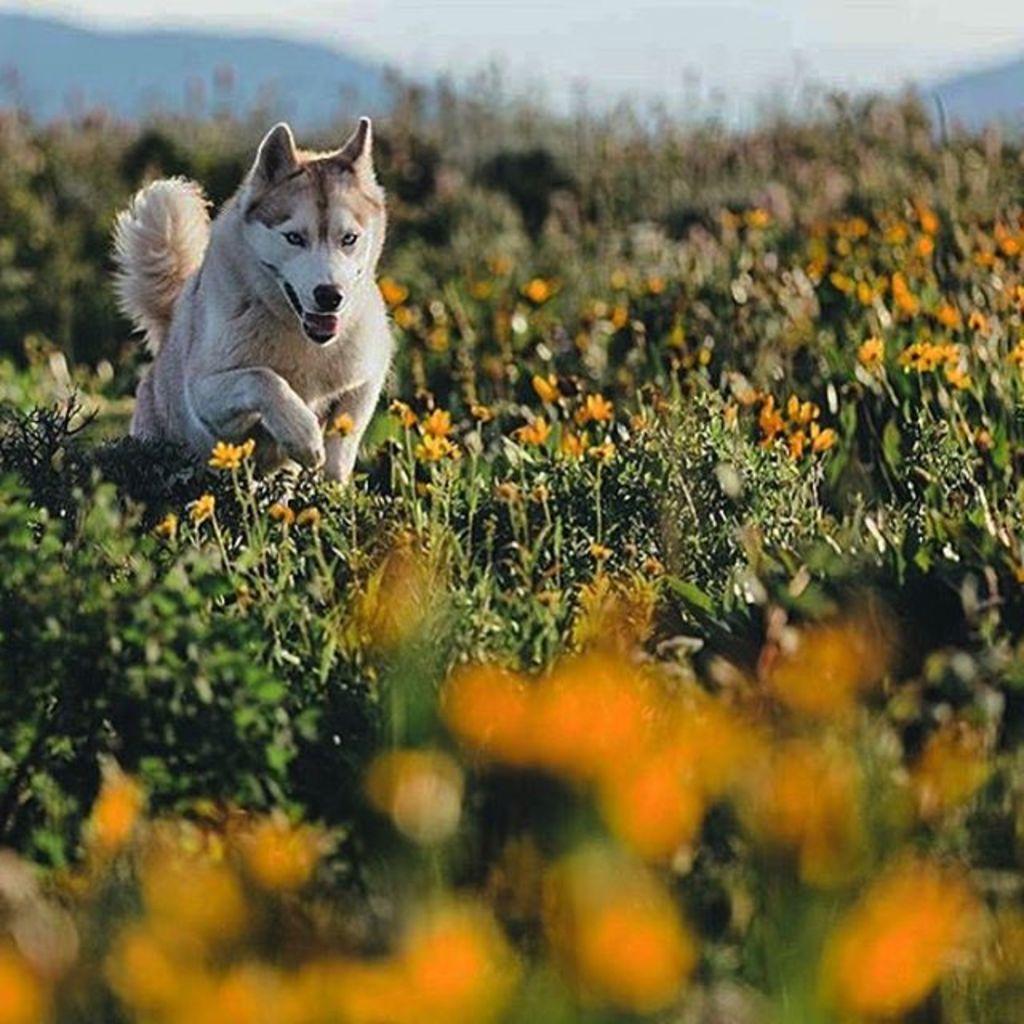Can you describe this image briefly? In the image there is a garden with many flowers and there is a dog in between the garden. 